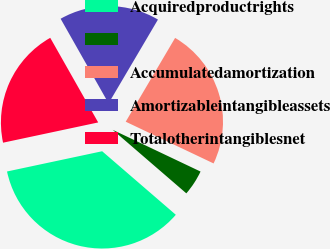<chart> <loc_0><loc_0><loc_500><loc_500><pie_chart><fcel>Acquiredproductrights<fcel>Unnamed: 1<fcel>Accumulatedamortization<fcel>Amortizableintangibleassets<fcel>Totalotherintangiblesnet<nl><fcel>35.33%<fcel>4.27%<fcel>23.58%<fcel>16.68%<fcel>20.13%<nl></chart> 